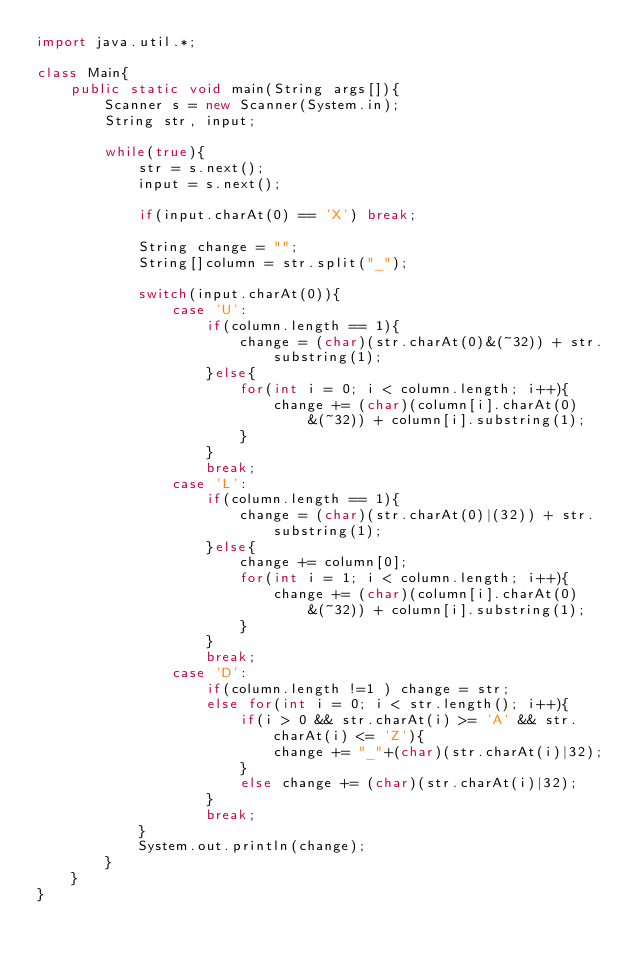Convert code to text. <code><loc_0><loc_0><loc_500><loc_500><_Java_>import java.util.*;

class Main{
    public static void main(String args[]){
        Scanner s = new Scanner(System.in);
        String str, input;

        while(true){
            str = s.next();
            input = s.next();

            if(input.charAt(0) == 'X') break;

            String change = "";
            String[]column = str.split("_");
            
            switch(input.charAt(0)){
                case 'U':
                    if(column.length == 1){
                        change = (char)(str.charAt(0)&(~32)) + str.substring(1);
                    }else{
                        for(int i = 0; i < column.length; i++){
                            change += (char)(column[i].charAt(0)&(~32)) + column[i].substring(1);
                        }
                    }
                    break;
                case 'L':
                    if(column.length == 1){
                        change = (char)(str.charAt(0)|(32)) + str.substring(1);
                    }else{
                        change += column[0];
                        for(int i = 1; i < column.length; i++){
                            change += (char)(column[i].charAt(0)&(~32)) + column[i].substring(1);
                        }
                    }
                    break;
                case 'D':
                    if(column.length !=1 ) change = str;
                    else for(int i = 0; i < str.length(); i++){
                        if(i > 0 && str.charAt(i) >= 'A' && str.charAt(i) <= 'Z'){
                            change += "_"+(char)(str.charAt(i)|32);
                        }
                        else change += (char)(str.charAt(i)|32);
                    }
                    break;
            }
            System.out.println(change);
        }
    }
}</code> 